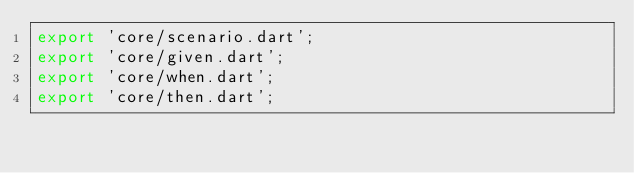Convert code to text. <code><loc_0><loc_0><loc_500><loc_500><_Dart_>export 'core/scenario.dart';
export 'core/given.dart';
export 'core/when.dart';
export 'core/then.dart';

</code> 